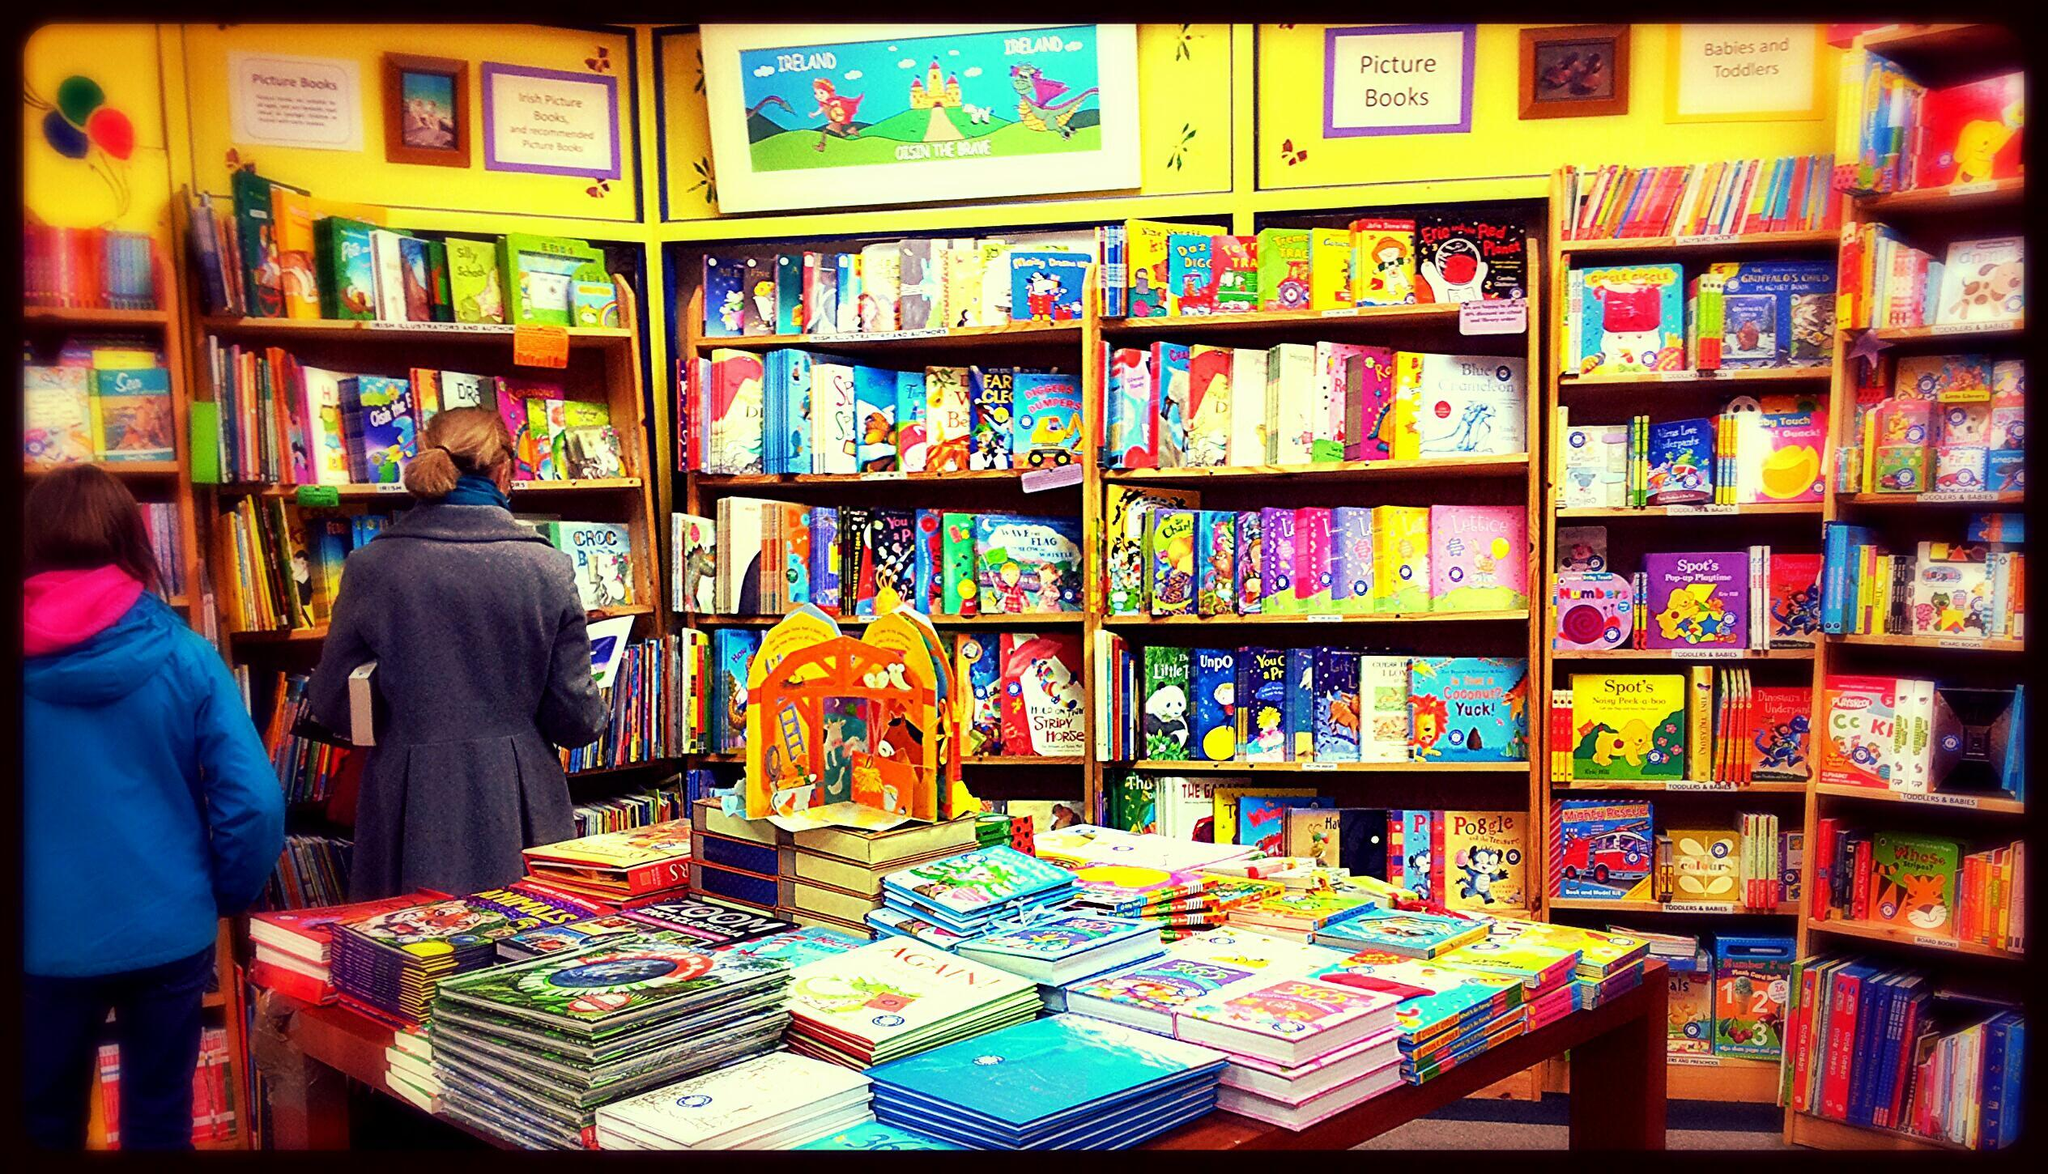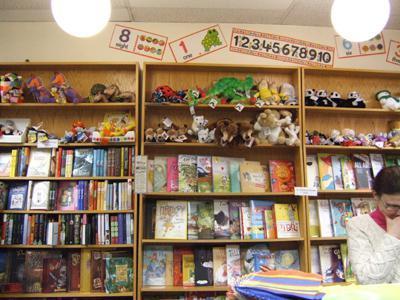The first image is the image on the left, the second image is the image on the right. Evaluate the accuracy of this statement regarding the images: "There is at least one person in the image on the right.". Is it true? Answer yes or no. Yes. The first image is the image on the left, the second image is the image on the right. Examine the images to the left and right. Is the description "In one image, the bookshelves themselves are bright yellow." accurate? Answer yes or no. Yes. 